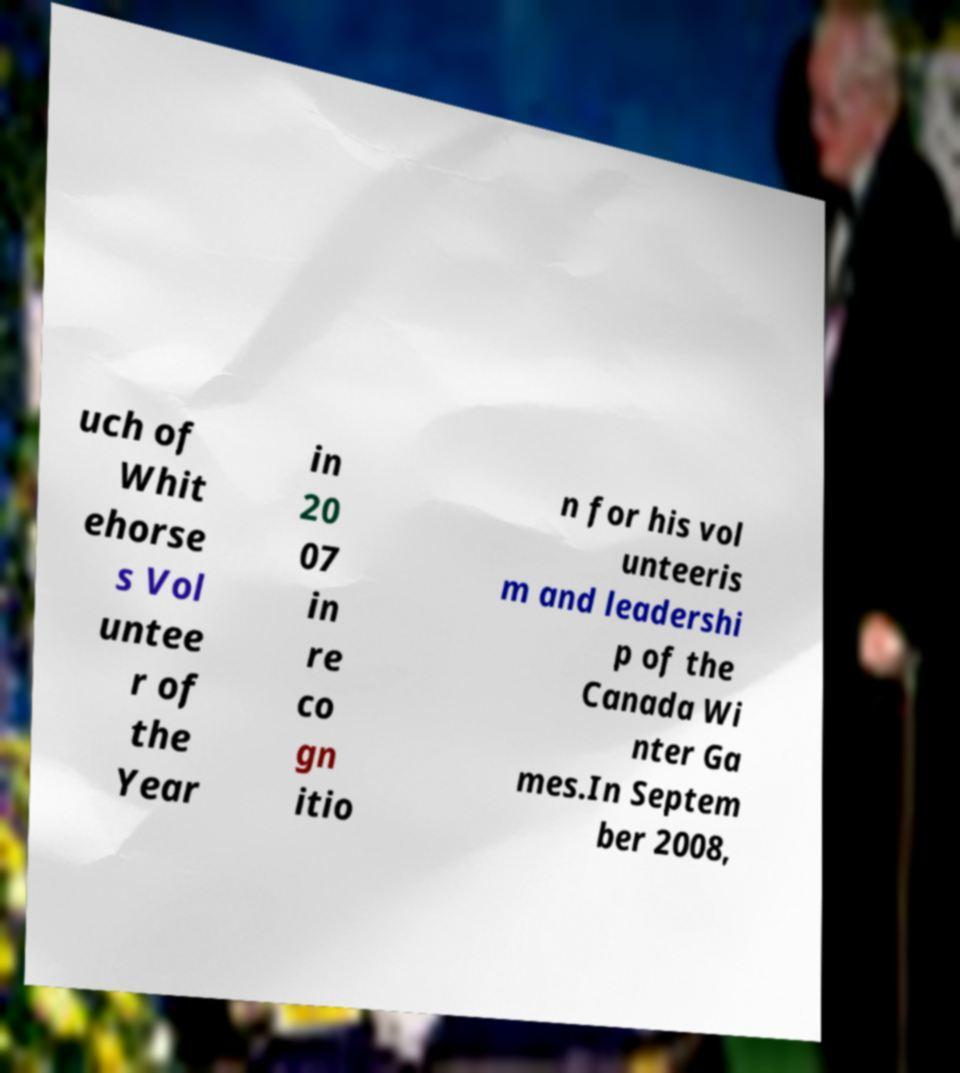Please identify and transcribe the text found in this image. uch of Whit ehorse s Vol untee r of the Year in 20 07 in re co gn itio n for his vol unteeris m and leadershi p of the Canada Wi nter Ga mes.In Septem ber 2008, 